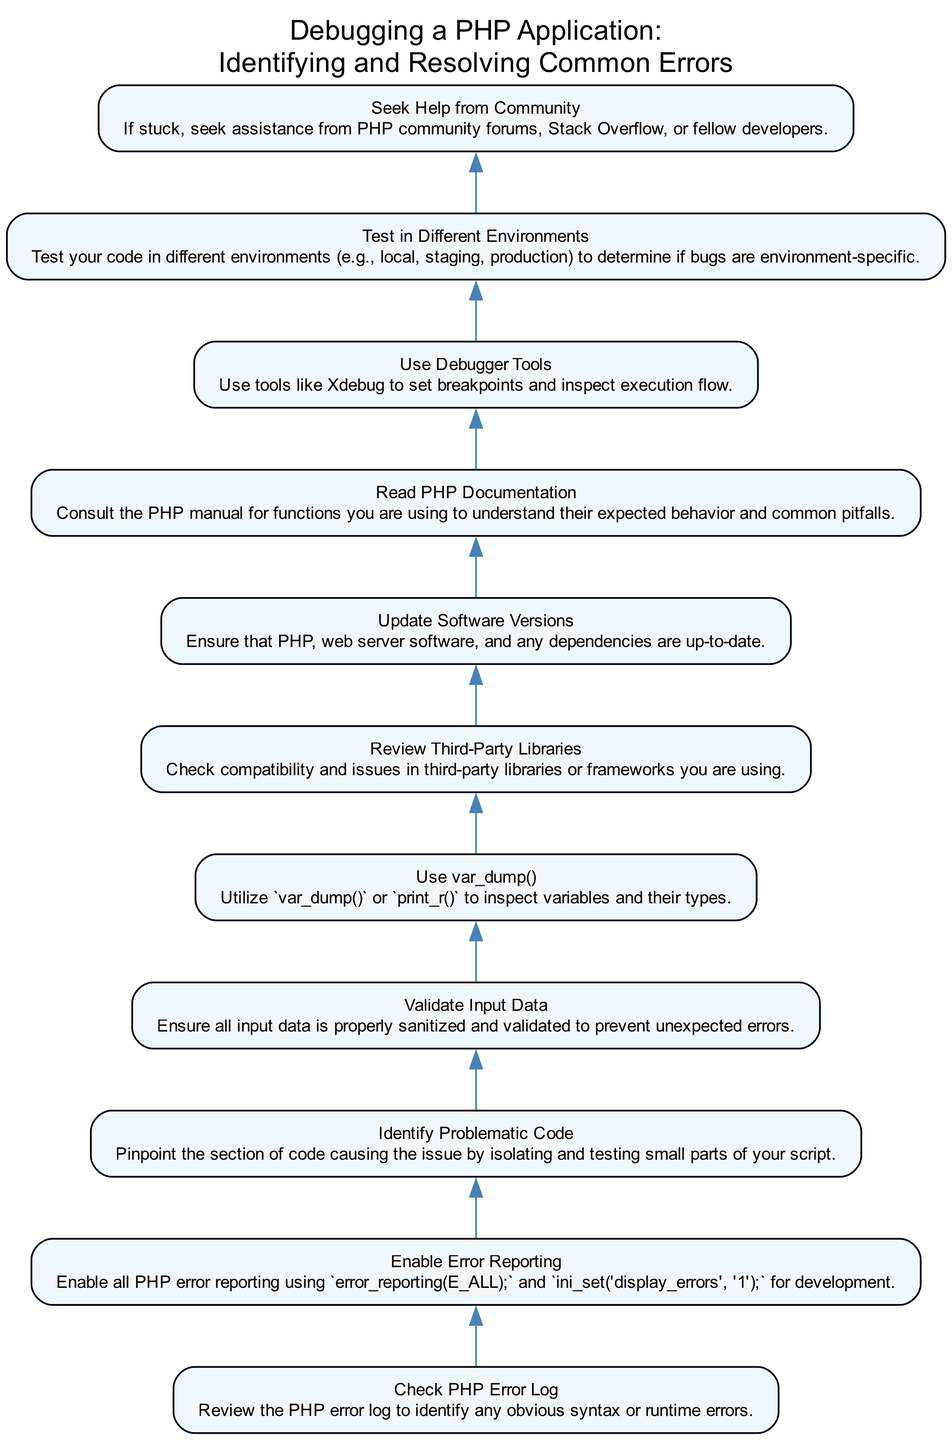What is the first step in debugging a PHP application according to the diagram? The diagram begins with the step "Check PHP Error Log," which is positioned at the bottom of the flow chart, indicating that it's the initial action to take.
Answer: Check PHP Error Log What node appears after "Enable Error Reporting"? According to the flow, after "Enable Error Reporting," the next action to take is "Identify Problematic Code," as shown by the upward connection in the diagram.
Answer: Identify Problematic Code How many steps are included in the debugging process? Counting the nodes in the diagram, there are a total of eleven steps that guide the debugging process.
Answer: Eleven Which step involves checking third-party components? The diagram includes the step "Review Third-Party Libraries," which is critical for examining compatibility and potential issues with any external libraries being used.
Answer: Review Third-Party Libraries What tool is suggested for inspecting execution flow? The diagram specifically highlights "Use Debugger Tools," which suggests using a tool like Xdebug for setting breakpoints and inspecting how the code executes.
Answer: Use Debugger Tools What should you do if you are stuck in the debugging process? According to the diagram, when stuck, you should "Seek Help from Community," which encourages reaching out to online forums or fellow developers for assistance.
Answer: Seek Help from Community Does the diagram suggest updating software versions? Yes, the step "Update Software Versions" explicitly indicates that keeping PHP and other related software up-to-date is essential in the debugging process, as shown in the diagram.
Answer: Yes What should you do to ensure input data is correct? The diagram includes the step "Validate Input Data," which emphasizes the importance of ensuring all input data is properly sanitized and validated to prevent unexpected errors.
Answer: Validate Input Data What is the relationship between "Use var_dump()" and inspecting variables? The diagram shows that "Use var_dump()" is crucial for inspecting variables and their types, indicating that it's a step specifically dedicated to troubleshooting variable-related issues.
Answer: Use var_dump() 